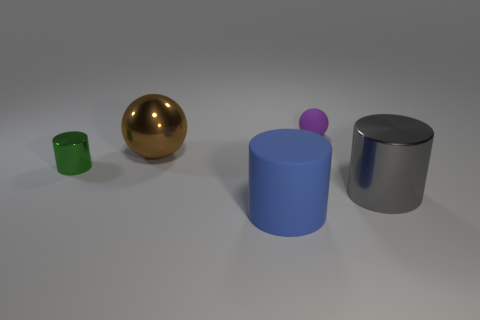Add 2 large blue matte things. How many objects exist? 7 Subtract all cylinders. How many objects are left? 2 Subtract 0 gray blocks. How many objects are left? 5 Subtract all purple rubber balls. Subtract all large gray metallic things. How many objects are left? 3 Add 4 blue objects. How many blue objects are left? 5 Add 3 matte spheres. How many matte spheres exist? 4 